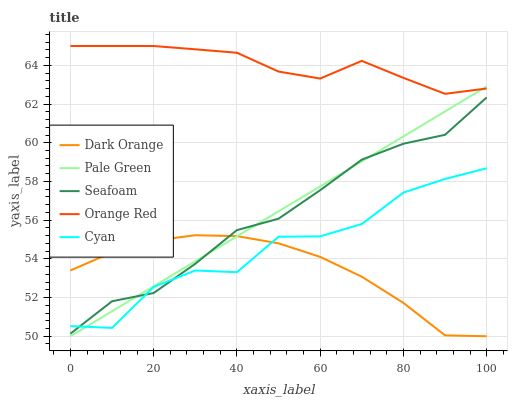Does Dark Orange have the minimum area under the curve?
Answer yes or no. Yes. Does Orange Red have the maximum area under the curve?
Answer yes or no. Yes. Does Cyan have the minimum area under the curve?
Answer yes or no. No. Does Cyan have the maximum area under the curve?
Answer yes or no. No. Is Pale Green the smoothest?
Answer yes or no. Yes. Is Cyan the roughest?
Answer yes or no. Yes. Is Cyan the smoothest?
Answer yes or no. No. Is Pale Green the roughest?
Answer yes or no. No. Does Dark Orange have the lowest value?
Answer yes or no. Yes. Does Cyan have the lowest value?
Answer yes or no. No. Does Orange Red have the highest value?
Answer yes or no. Yes. Does Cyan have the highest value?
Answer yes or no. No. Is Seafoam less than Orange Red?
Answer yes or no. Yes. Is Orange Red greater than Seafoam?
Answer yes or no. Yes. Does Pale Green intersect Seafoam?
Answer yes or no. Yes. Is Pale Green less than Seafoam?
Answer yes or no. No. Is Pale Green greater than Seafoam?
Answer yes or no. No. Does Seafoam intersect Orange Red?
Answer yes or no. No. 